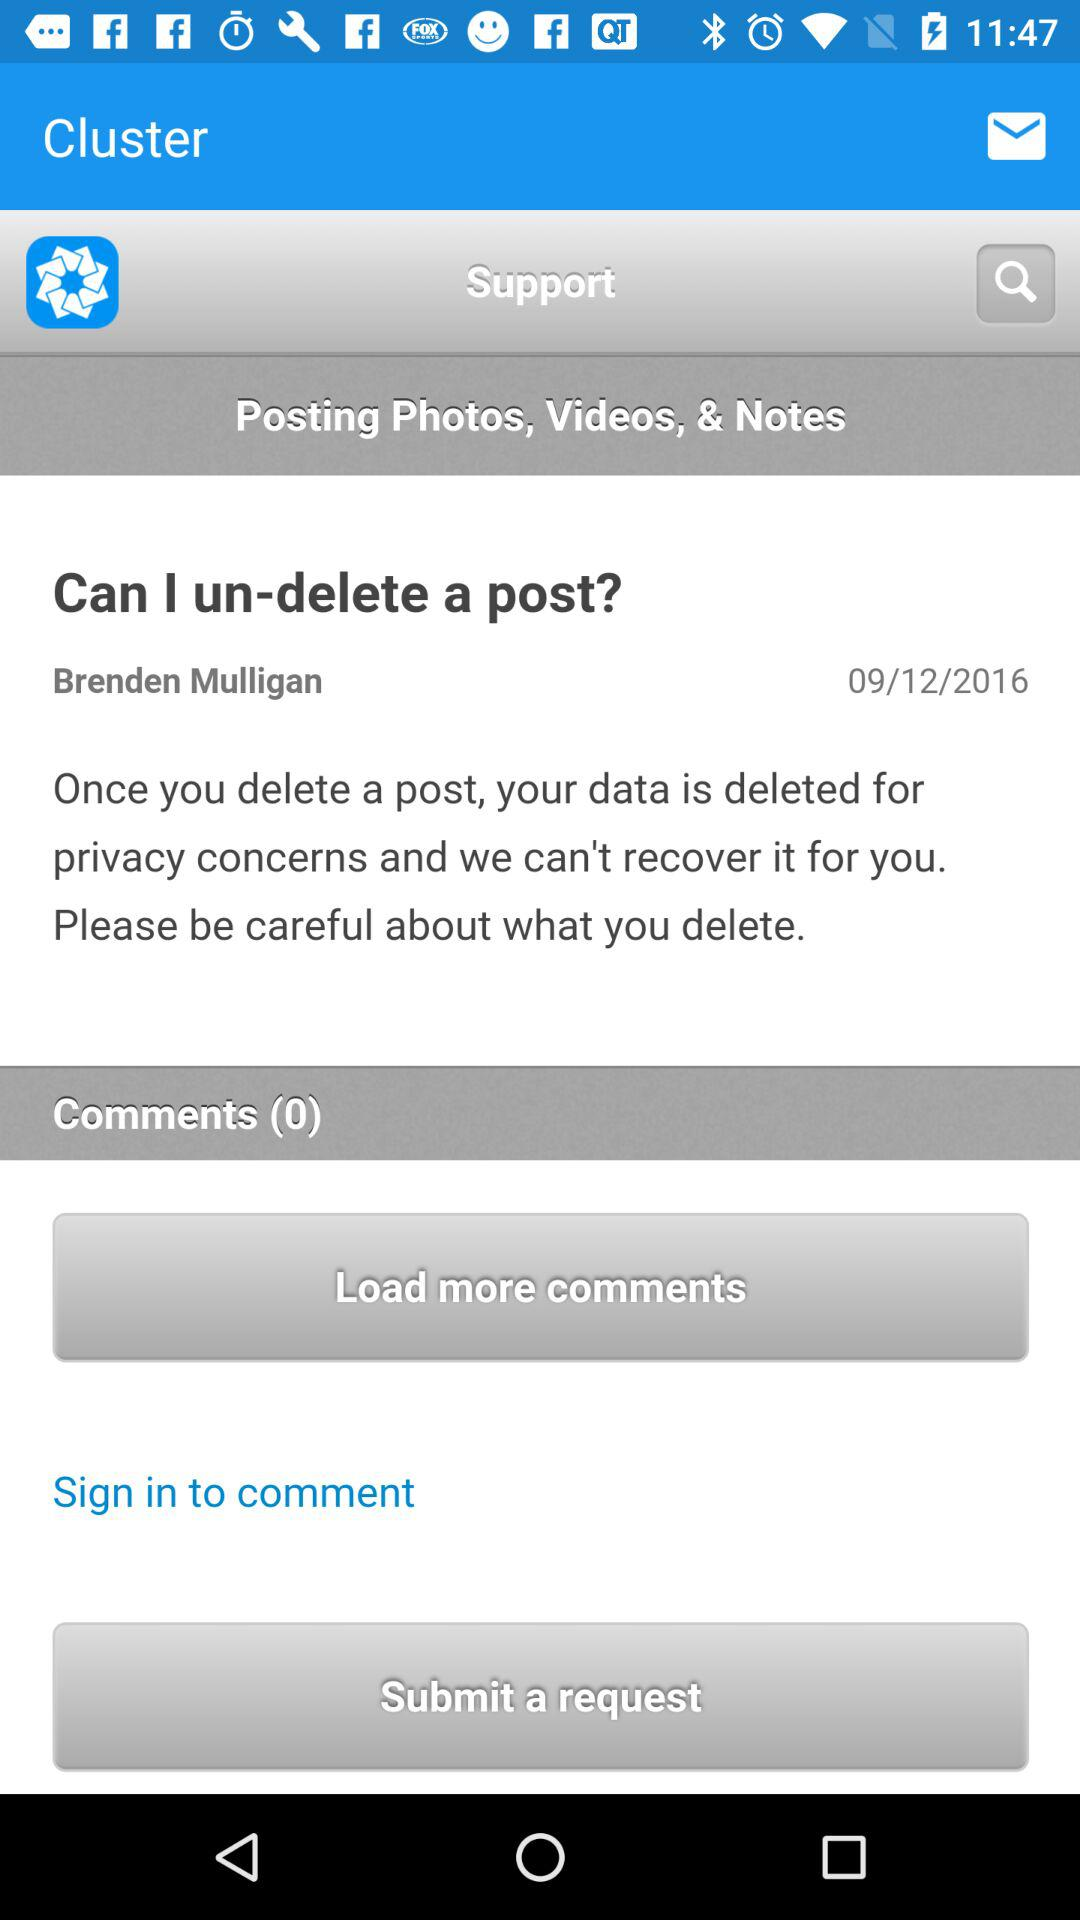How many comments are received? There are 0 comments received. 